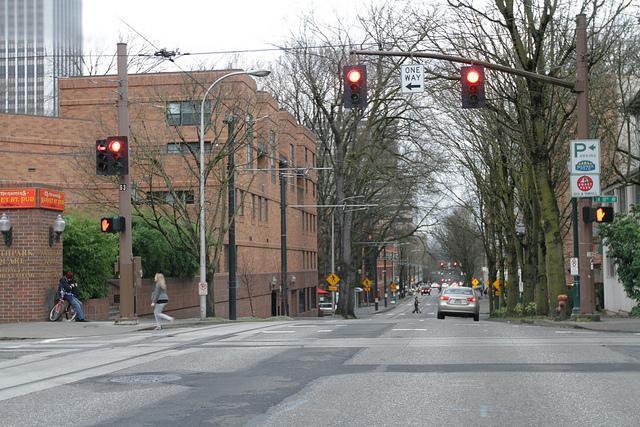How many giraffes are in the picture?
Give a very brief answer. 0. 